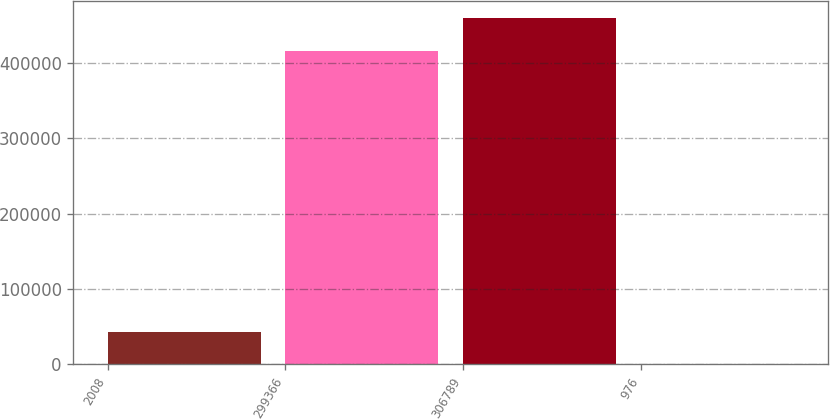Convert chart to OTSL. <chart><loc_0><loc_0><loc_500><loc_500><bar_chart><fcel>2008<fcel>299366<fcel>306789<fcel>976<nl><fcel>42805.4<fcel>416303<fcel>459011<fcel>97.5<nl></chart> 